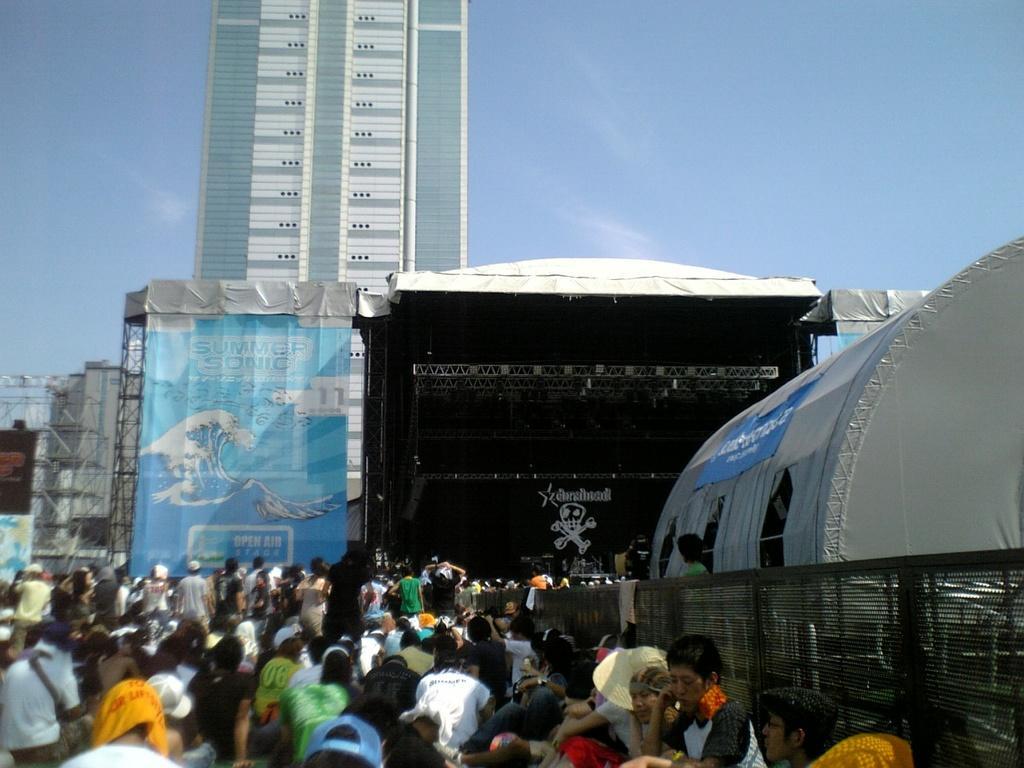How would you summarize this image in a sentence or two? In front of the image there are a few people sitting. There are a few standing. There are a few objects on the stage. There is a roof top supported by metal rods. On the right side of the image there are clothes on the metal fence. There is a tent. In the background of the image there are banners, buildings. At the top of the image there is sky. 